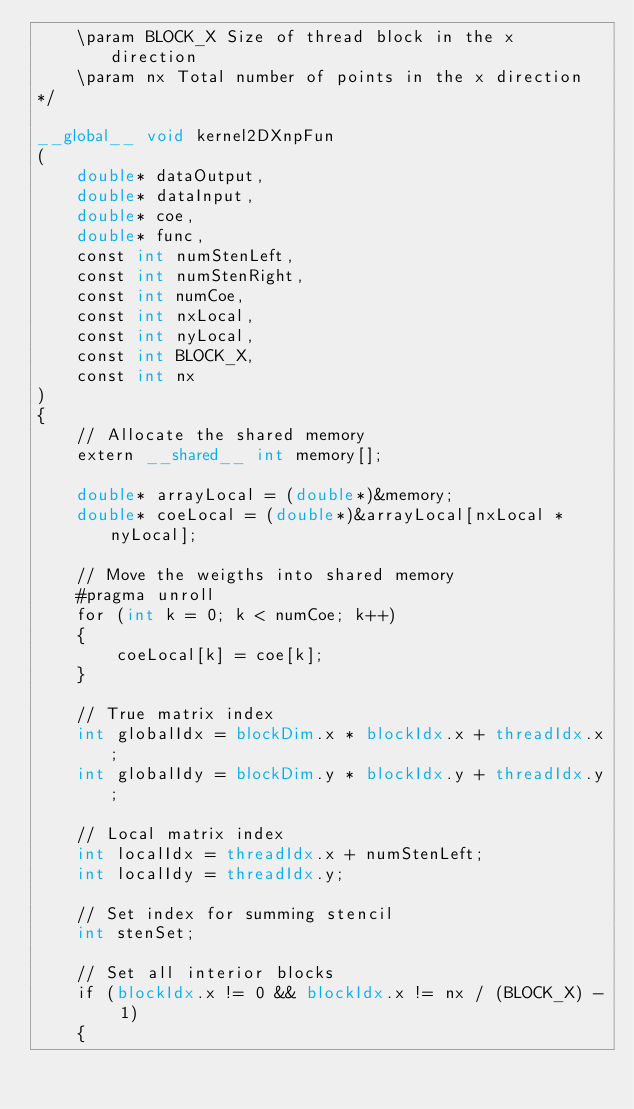<code> <loc_0><loc_0><loc_500><loc_500><_Cuda_>	\param BLOCK_X Size of thread block in the x direction
	\param nx Total number of points in the x direction
*/

__global__ void kernel2DXnpFun
(
	double* dataOutput,  				
	double* dataInput,					
	double* coe,						
	double* func,						
	const int numStenLeft,				
	const int numStenRight,				
	const int numCoe,				
	const int nxLocal,					
	const int nyLocal,					
	const int BLOCK_X,					
	const int nx
)
{	
	// Allocate the shared memory
	extern __shared__ int memory[];

	double* arrayLocal = (double*)&memory;
	double* coeLocal = (double*)&arrayLocal[nxLocal * nyLocal];

	// Move the weigths into shared memory
	#pragma unroll
	for (int k = 0; k < numCoe; k++)
	{
		coeLocal[k] = coe[k];
	}

	// True matrix index
    int globalIdx = blockDim.x * blockIdx.x + threadIdx.x;
	int globalIdy = blockDim.y * blockIdx.y + threadIdx.y;

	// Local matrix index
	int localIdx = threadIdx.x + numStenLeft;
	int localIdy = threadIdx.y;

	// Set index for summing stencil
	int stenSet;

	// Set all interior blocks
	if (blockIdx.x != 0 && blockIdx.x != nx / (BLOCK_X) - 1)
	{</code> 